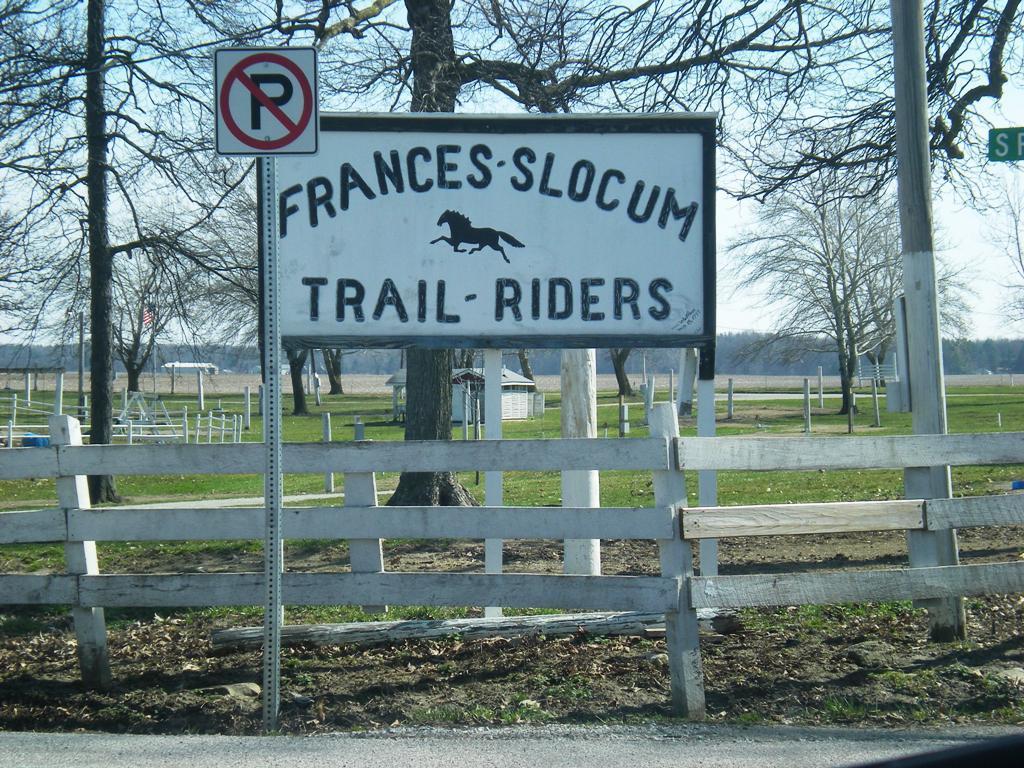How would you summarize this image in a sentence or two? In this image we can see one small house, one road, two name boards, one stick, some objects are on the surface, one pole with sign board, so many trees and some grass on the ground. There is a fence around the ground and at the top there is the sky. 